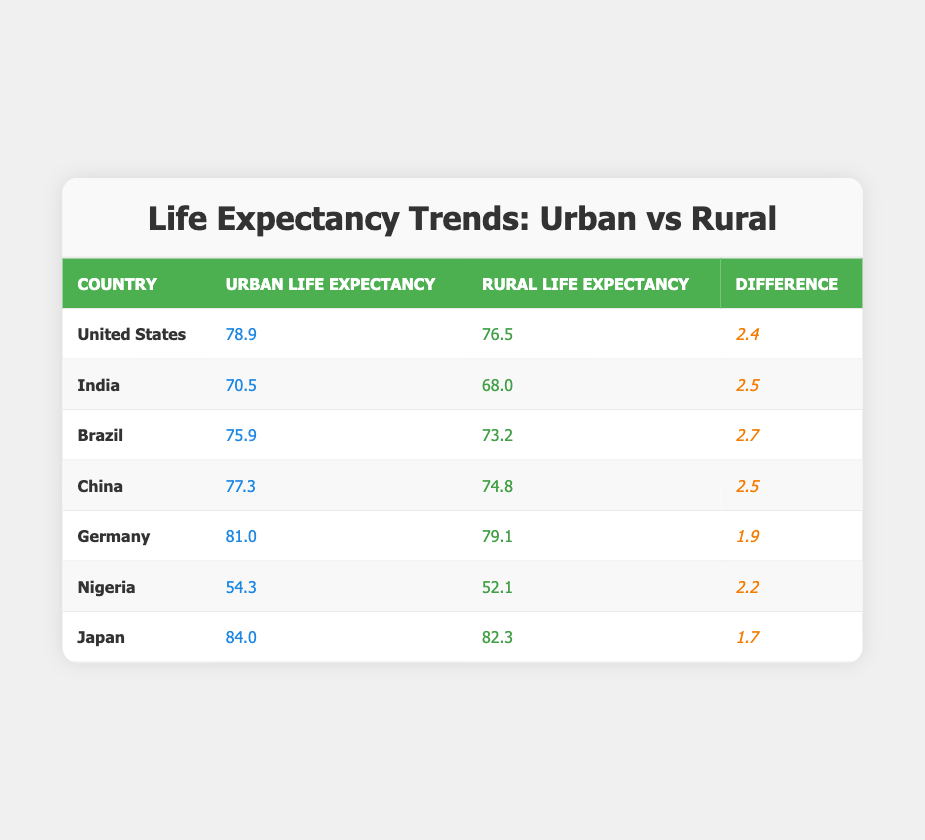What is the urban life expectancy in Germany? The table lists the urban life expectancy for Germany as 81.0 years.
Answer: 81.0 What is the rural life expectancy in India? The rural life expectancy for India is provided in the table as 68.0 years.
Answer: 68.0 Which country has the highest urban life expectancy? According to the table, Japan has the highest urban life expectancy at 84.0 years.
Answer: Japan What is the difference in life expectancy between urban and rural populations in Brazil? The table shows that urban life expectancy in Brazil is 75.9 years and rural is 73.2 years. The difference is 75.9 - 73.2 = 2.7 years.
Answer: 2.7 Is the urban life expectancy in Nigeria higher than that in China? The table indicates that urban life expectancy in Nigeria is 54.3 years while in China it is 77.3 years, making Nigeria lower than China.
Answer: No What is the average rural life expectancy across all listed countries? To find the average rural life expectancy, we sum the rural life expectancies: 76.5 + 68.0 + 73.2 + 74.8 + 79.1 + 52.1 + 82.3 = 505.0 years. There are 7 countries, so the average is 505.0 / 7 ≈ 72.14 years.
Answer: 72.14 Which country has the smallest difference between urban and rural life expectancy? The table reveals that Germany has the smallest difference at 1.9 years, when compared to all other countries.
Answer: Germany Are the rural populations of all the listed countries having a life expectancy lower than 80 years? Looking at the table, the rural life expectancy for the countries listed shows that the values for Nigeria (52.1), India (68.0), and Brazil (73.2) are below 80 years, while others exceed 80 years. Hence, not all rural populations are below 80.
Answer: No If we compare the differences in life expectancy between urban and rural populations, how many countries have a difference greater than 2.5 years? The table shows differences of 2.4, 2.5, 2.7, 2.5, 1.9, 2.2, and 1.7 years for the respective countries. The countries with differences greater than 2.5 are Brazil (2.7 years) only.
Answer: 1 